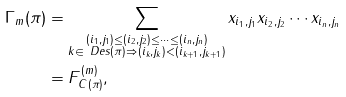Convert formula to latex. <formula><loc_0><loc_0><loc_500><loc_500>\Gamma _ { m } ( \pi ) & = \sum _ { \substack { ( i _ { 1 } , j _ { 1 } ) \leq ( i _ { 2 } , j _ { 2 } ) \leq \cdots \leq ( i _ { n } , j _ { n } ) \\ k \in \ D e s ( \pi ) \Rightarrow ( i _ { k } , j _ { k } ) < ( i _ { k + 1 } , j _ { k + 1 } ) } } x _ { i _ { 1 } , j _ { 1 } } x _ { i _ { 2 } , j _ { 2 } } \cdots x _ { i _ { n } , j _ { n } } \\ & = F ^ { ( m ) } _ { C ( \pi ) } ,</formula> 